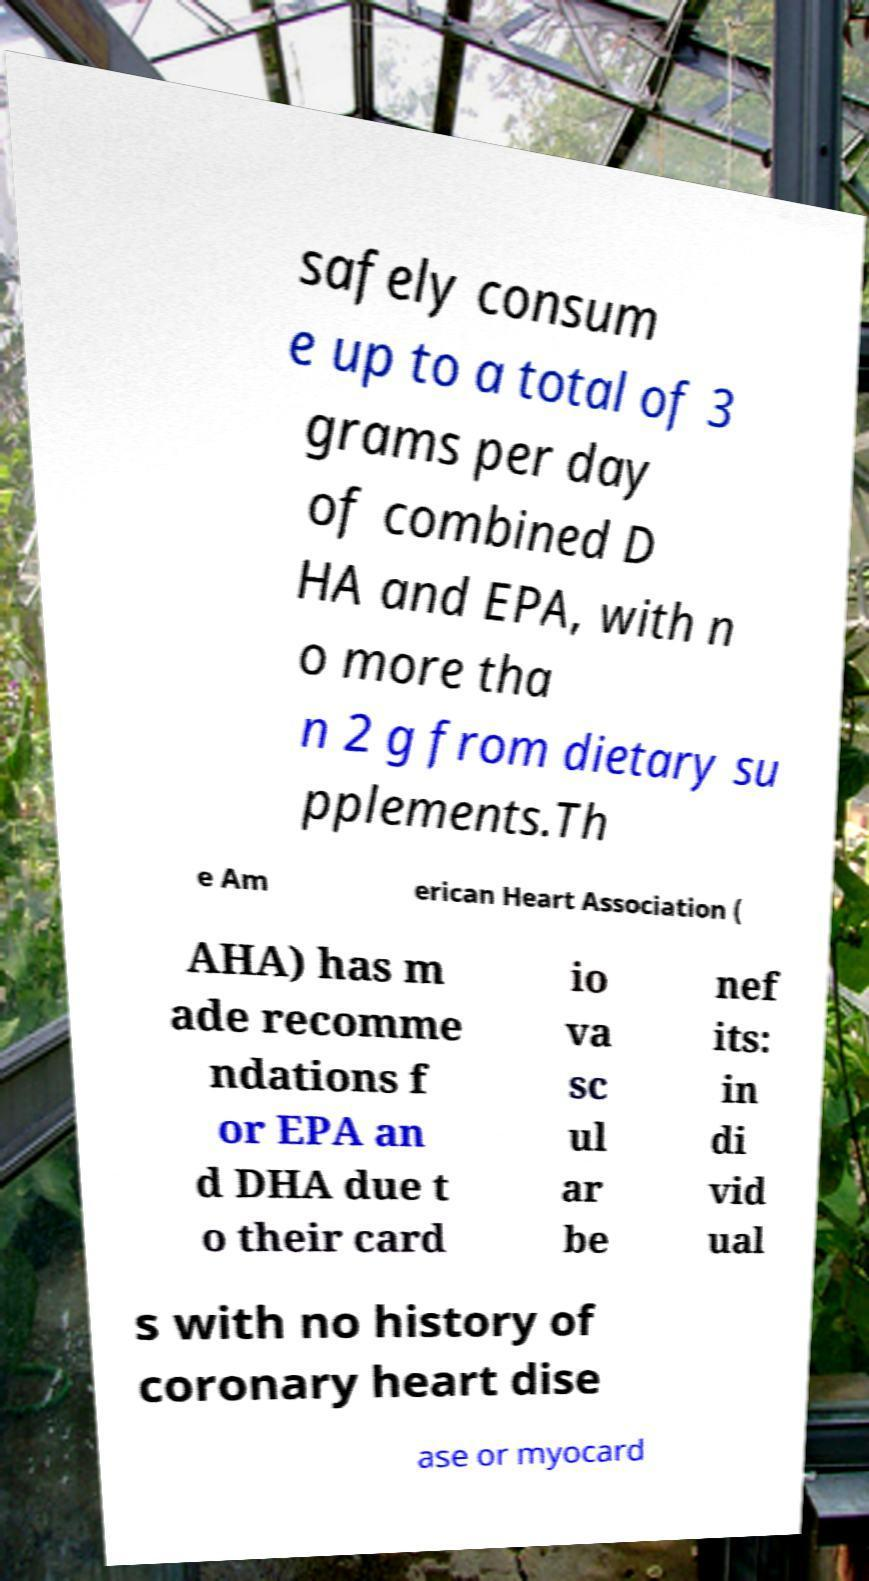Can you read and provide the text displayed in the image?This photo seems to have some interesting text. Can you extract and type it out for me? safely consum e up to a total of 3 grams per day of combined D HA and EPA, with n o more tha n 2 g from dietary su pplements.Th e Am erican Heart Association ( AHA) has m ade recomme ndations f or EPA an d DHA due t o their card io va sc ul ar be nef its: in di vid ual s with no history of coronary heart dise ase or myocard 